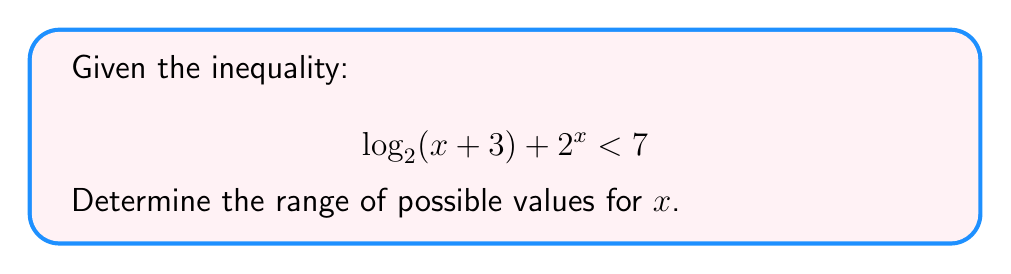Could you help me with this problem? Let's approach this step-by-step:

1) First, we need to consider the domain of the logarithm. For $\log_2(x+3)$ to be defined, we need:
   
   $x + 3 > 0$
   $x > -3$

2) Now, let's solve the inequality:
   
   $\log_2(x+3) + 2^x < 7$

3) We can't easily isolate $x$ due to the presence of both logarithmic and exponential terms. In such cases, it's often helpful to consider the behavior of each side separately.

4) Let $f(x) = \log_2(x+3) + 2^x$ and $g(x) = 7$

5) Observe that:
   - As $x$ approaches $-3$ from the right, $\log_2(x+3)$ approaches negative infinity while $2^x$ approaches $\frac{1}{8}$.
   - As $x$ increases, both $\log_2(x+3)$ and $2^x$ increase, but $2^x$ grows much faster.

6) Therefore, $f(x)$ is continuous and strictly increasing for $x > -3$.

7) We can find the solution by determining where $f(x) = 7$:
   
   $\log_2(x+3) + 2^x = 7$

8) This equation can't be solved algebraically, but we can approximate its solution numerically. Using a calculator or computer, we find that this equation is satisfied when $x \approx 2.4019$.

9) Given that $f(x)$ is strictly increasing, the inequality $f(x) < 7$ is satisfied when $x < 2.4019$.

10) Combining this with the domain restriction from step 1, we get the final solution.
Answer: The range of possible values for $x$ is:

$$-3 < x < 2.4019$$ 